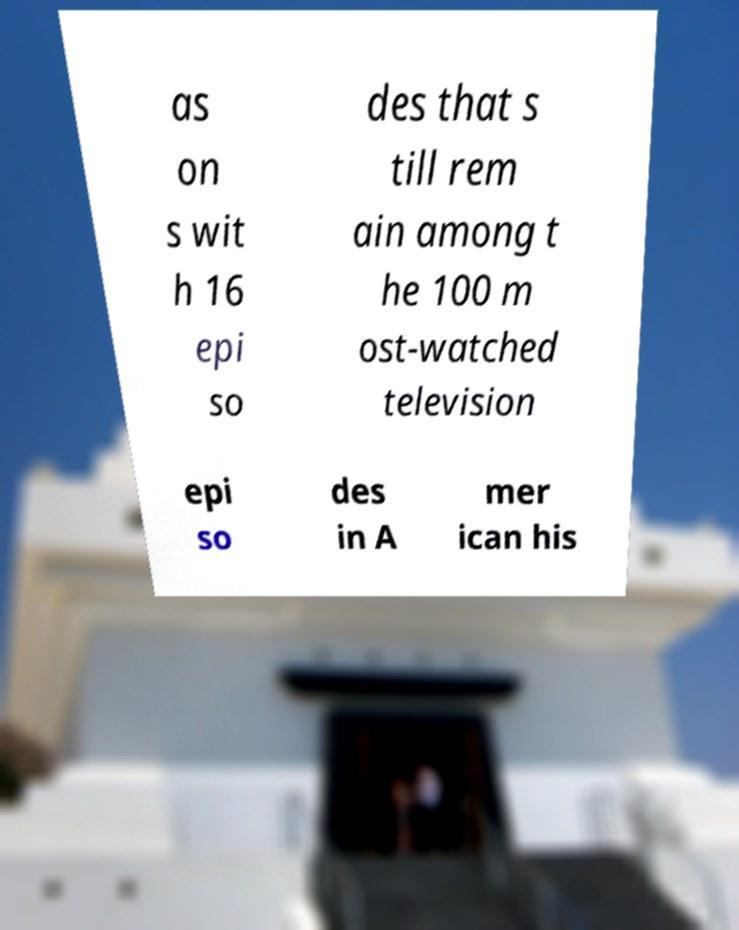Please read and relay the text visible in this image. What does it say? as on s wit h 16 epi so des that s till rem ain among t he 100 m ost-watched television epi so des in A mer ican his 